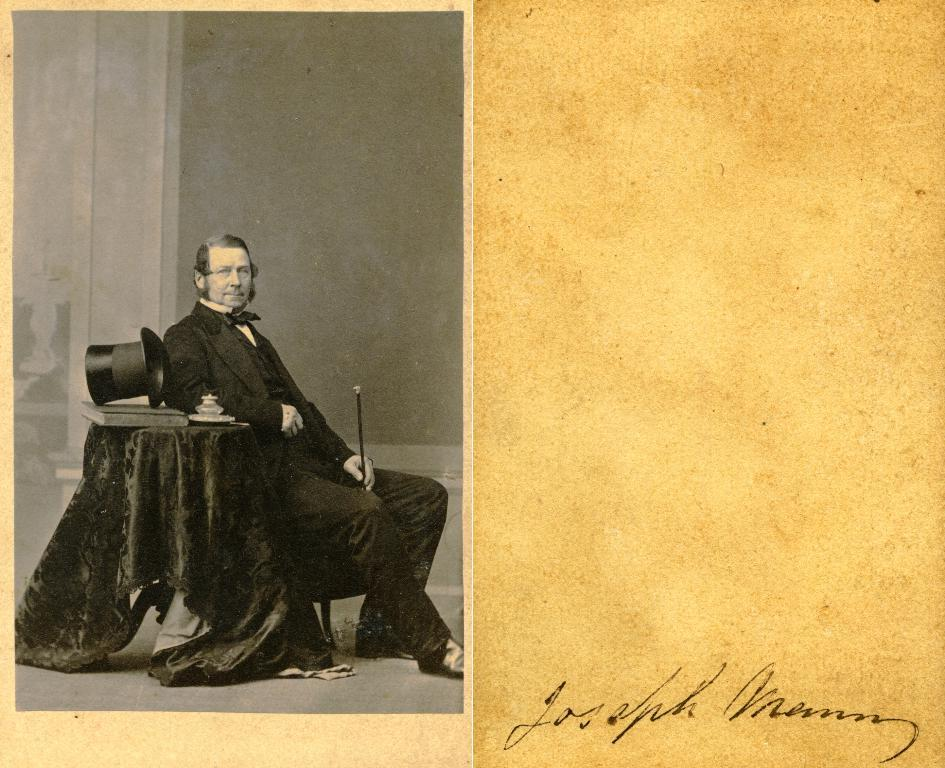What is the main object in the image? There is a chart paper in the image. What is happening on the chart paper? A person is sitting on a chair on the chart paper. Can you identify any markings on the chart paper? Yes, there is a signature visible on the chart paper. What type of vegetable is being used as a noise-cancelling device in the image? There is no vegetable or noise-cancelling device present in the image. 